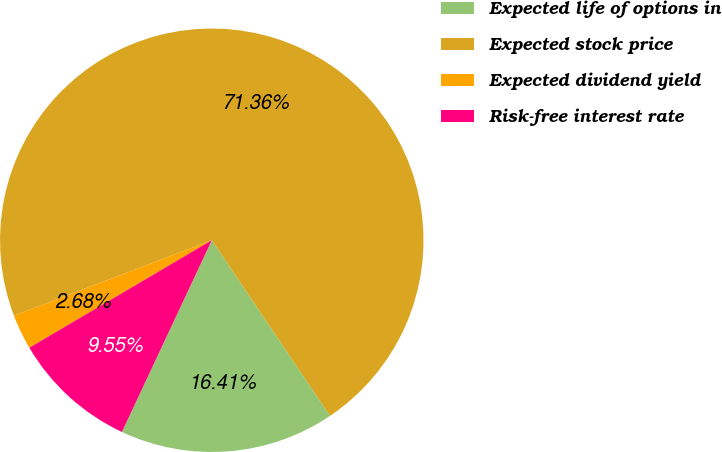Convert chart. <chart><loc_0><loc_0><loc_500><loc_500><pie_chart><fcel>Expected life of options in<fcel>Expected stock price<fcel>Expected dividend yield<fcel>Risk-free interest rate<nl><fcel>16.41%<fcel>71.36%<fcel>2.68%<fcel>9.55%<nl></chart> 